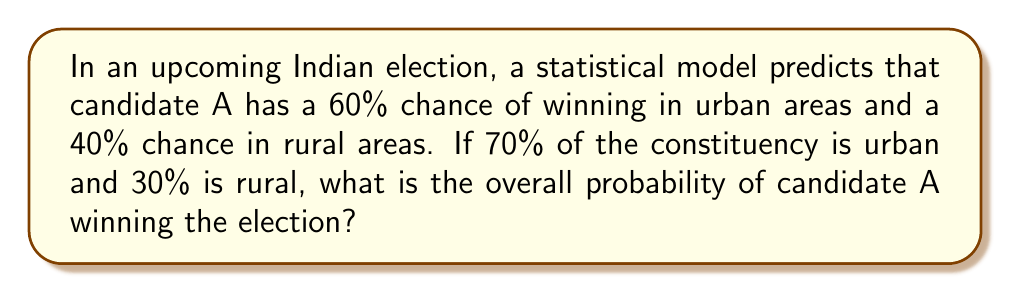Help me with this question. Let's approach this step-by-step using the law of total probability:

1) Let's define our events:
   U: The voter is from an urban area
   R: The voter is from a rural area
   W: Candidate A wins

2) We're given the following probabilities:
   P(U) = 0.70 (70% urban)
   P(R) = 0.30 (30% rural)
   P(W|U) = 0.60 (60% chance of winning in urban areas)
   P(W|R) = 0.40 (40% chance of winning in rural areas)

3) The law of total probability states:
   $$P(W) = P(W|U) \cdot P(U) + P(W|R) \cdot P(R)$$

4) Let's substitute our values:
   $$P(W) = 0.60 \cdot 0.70 + 0.40 \cdot 0.30$$

5) Now we can calculate:
   $$P(W) = 0.42 + 0.12 = 0.54$$

6) Convert to a percentage:
   0.54 * 100 = 54%

Therefore, the overall probability of candidate A winning the election is 54%.
Answer: 54% 